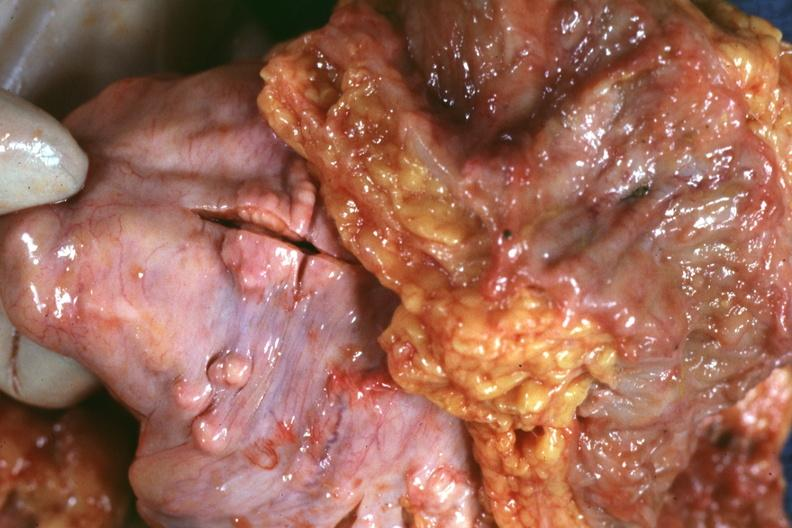does omphalocele show view of rectovesical pouch with obvious tumor nodules beneath peritoneum very good example?
Answer the question using a single word or phrase. No 